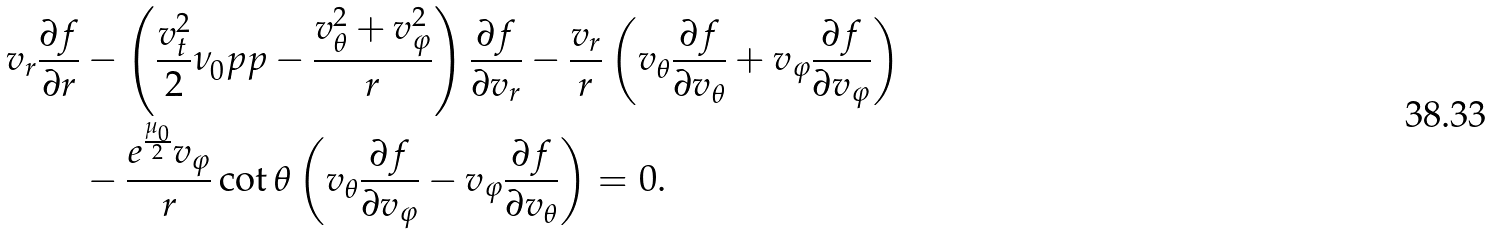<formula> <loc_0><loc_0><loc_500><loc_500>v _ { r } \frac { \partial f } { \partial r } & - \left ( \frac { v ^ { 2 } _ { t } } { 2 } \nu _ { 0 } ^ { \ } p p - \frac { v ^ { 2 } _ { \theta } + v ^ { 2 } _ { \varphi } } { r } \right ) \frac { \partial f } { \partial v _ { r } } - \frac { v _ { r } } { r } \left ( v _ { \theta } \frac { \partial f } { \partial v _ { \theta } } + v _ { \varphi } \frac { \partial f } { \partial v _ { \varphi } } \right ) \\ & - \frac { e ^ { \frac { \mu _ { 0 } } { 2 } } v _ { \varphi } } { r } \cot \theta \left ( v _ { \theta } \frac { \partial f } { \partial v _ { \varphi } } - v _ { \varphi } \frac { \partial f } { \partial v _ { \theta } } \right ) = 0 .</formula> 